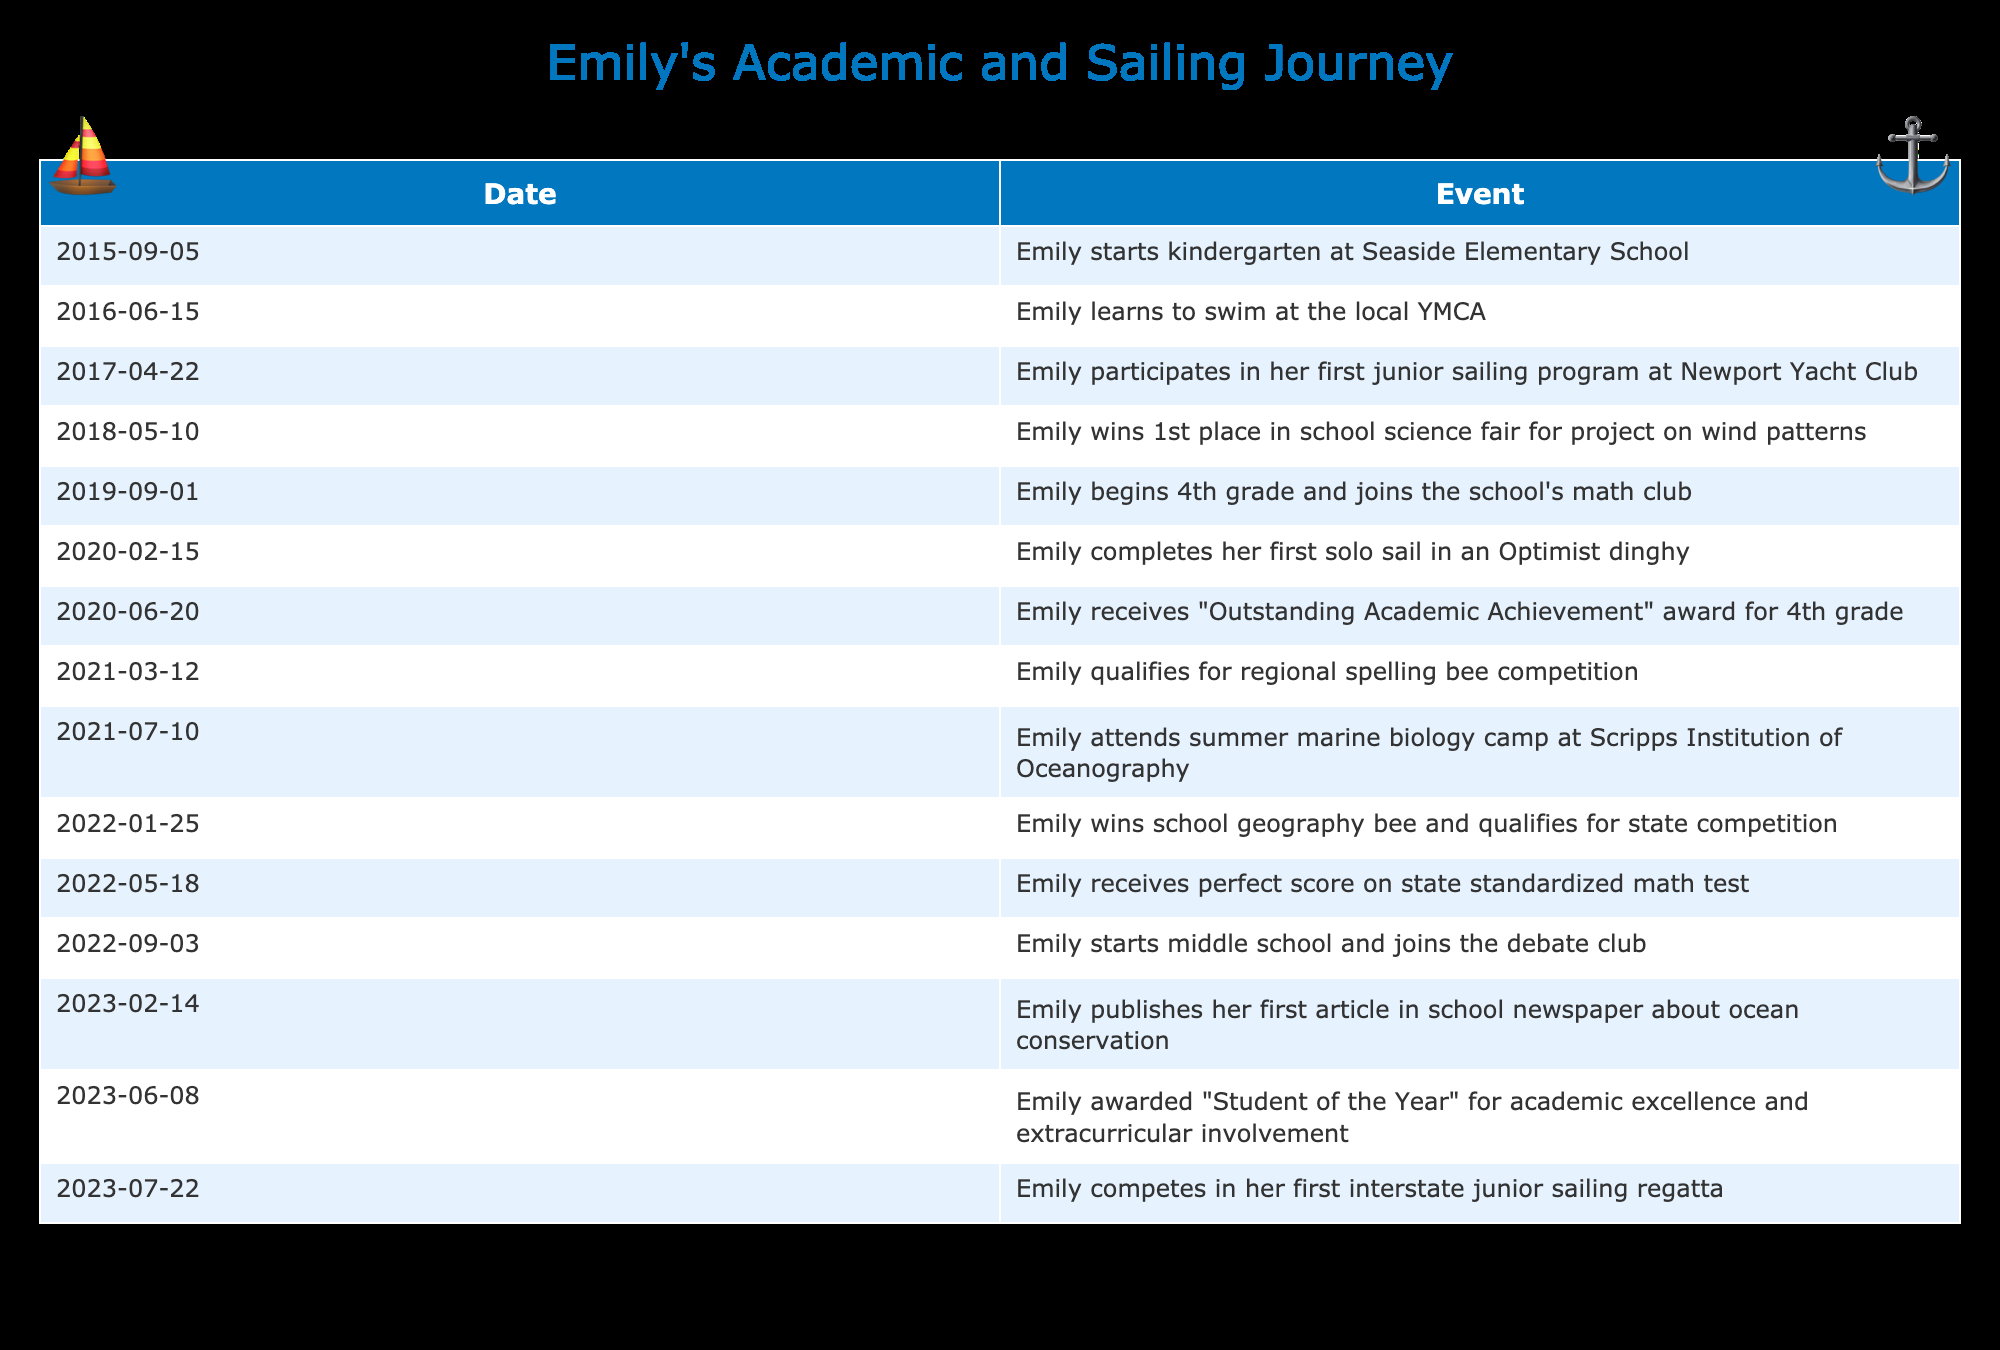What event did Emily participate in on April 22, 2017? The table lists an event on April 22, 2017, which states that Emily participated in her first junior sailing program at Newport Yacht Club.
Answer: Emily participated in her first junior sailing program at Newport Yacht Club Which award did Emily receive for her 4th-grade achievements? The table indicates that on June 20, 2020, Emily received the "Outstanding Academic Achievement" award for 4th grade.
Answer: Emily received the "Outstanding Academic Achievement" award for 4th grade Did Emily win the school geography bee? According to the table, Emily won the school geography bee on January 25, 2022, and qualified for the state competition, which indicates that she did win.
Answer: Yes How many extracurricular activities did Emily join from 2015 to 2023? By analyzing the table, Emily joined several activities: junior sailing program (2017), math club (2019), summer marine biology camp (2021), debate club (2022), school newspaper (2023), and participated in interstate junior sailing regatta (2023). Therefore, she joined six extracurricular activities.
Answer: 6 What was the gap between when Emily started kindergarten and when she first won an academic award? Emily started kindergarten on September 5, 2015, and received the "Outstanding Academic Achievement" award on June 20, 2020. The time between these two dates is approximately 4 years and 9 months.
Answer: 4 years and 9 months How did Emily’s performance in standardized math compare to her geography bee achievement? The table shows that Emily received a perfect score on her state standardized math test on May 18, 2022, and won the geography bee on January 25, 2022. While both are significant achievements, the standardized test was a perfect score, which is a very high level of accomplishment compared to winning the bee.
Answer: Standardized math test was a perfect score; geography bee was a win What percentage of the events involved sailing activities? The table has a total of 15 events. Out of these, four events directly relate to sailing (junior sailing program, solo sail, summer marine biology camp with marine focus, and interstate junior sailing regatta). To find the percentage, divide 4 by 15 and multiply by 100, which gives approximately 26.67%.
Answer: Approximately 26.67% Which year had the most academic achievements for Emily? By reviewing the events from the table, the year 2022 stands out with two significant achievements: winning the geography bee and receiving a perfect score on the state standardized math test. Counting these events indicates 2022 had the most academic achievements.
Answer: 2022 